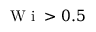<formula> <loc_0><loc_0><loc_500><loc_500>W i > 0 . 5</formula> 